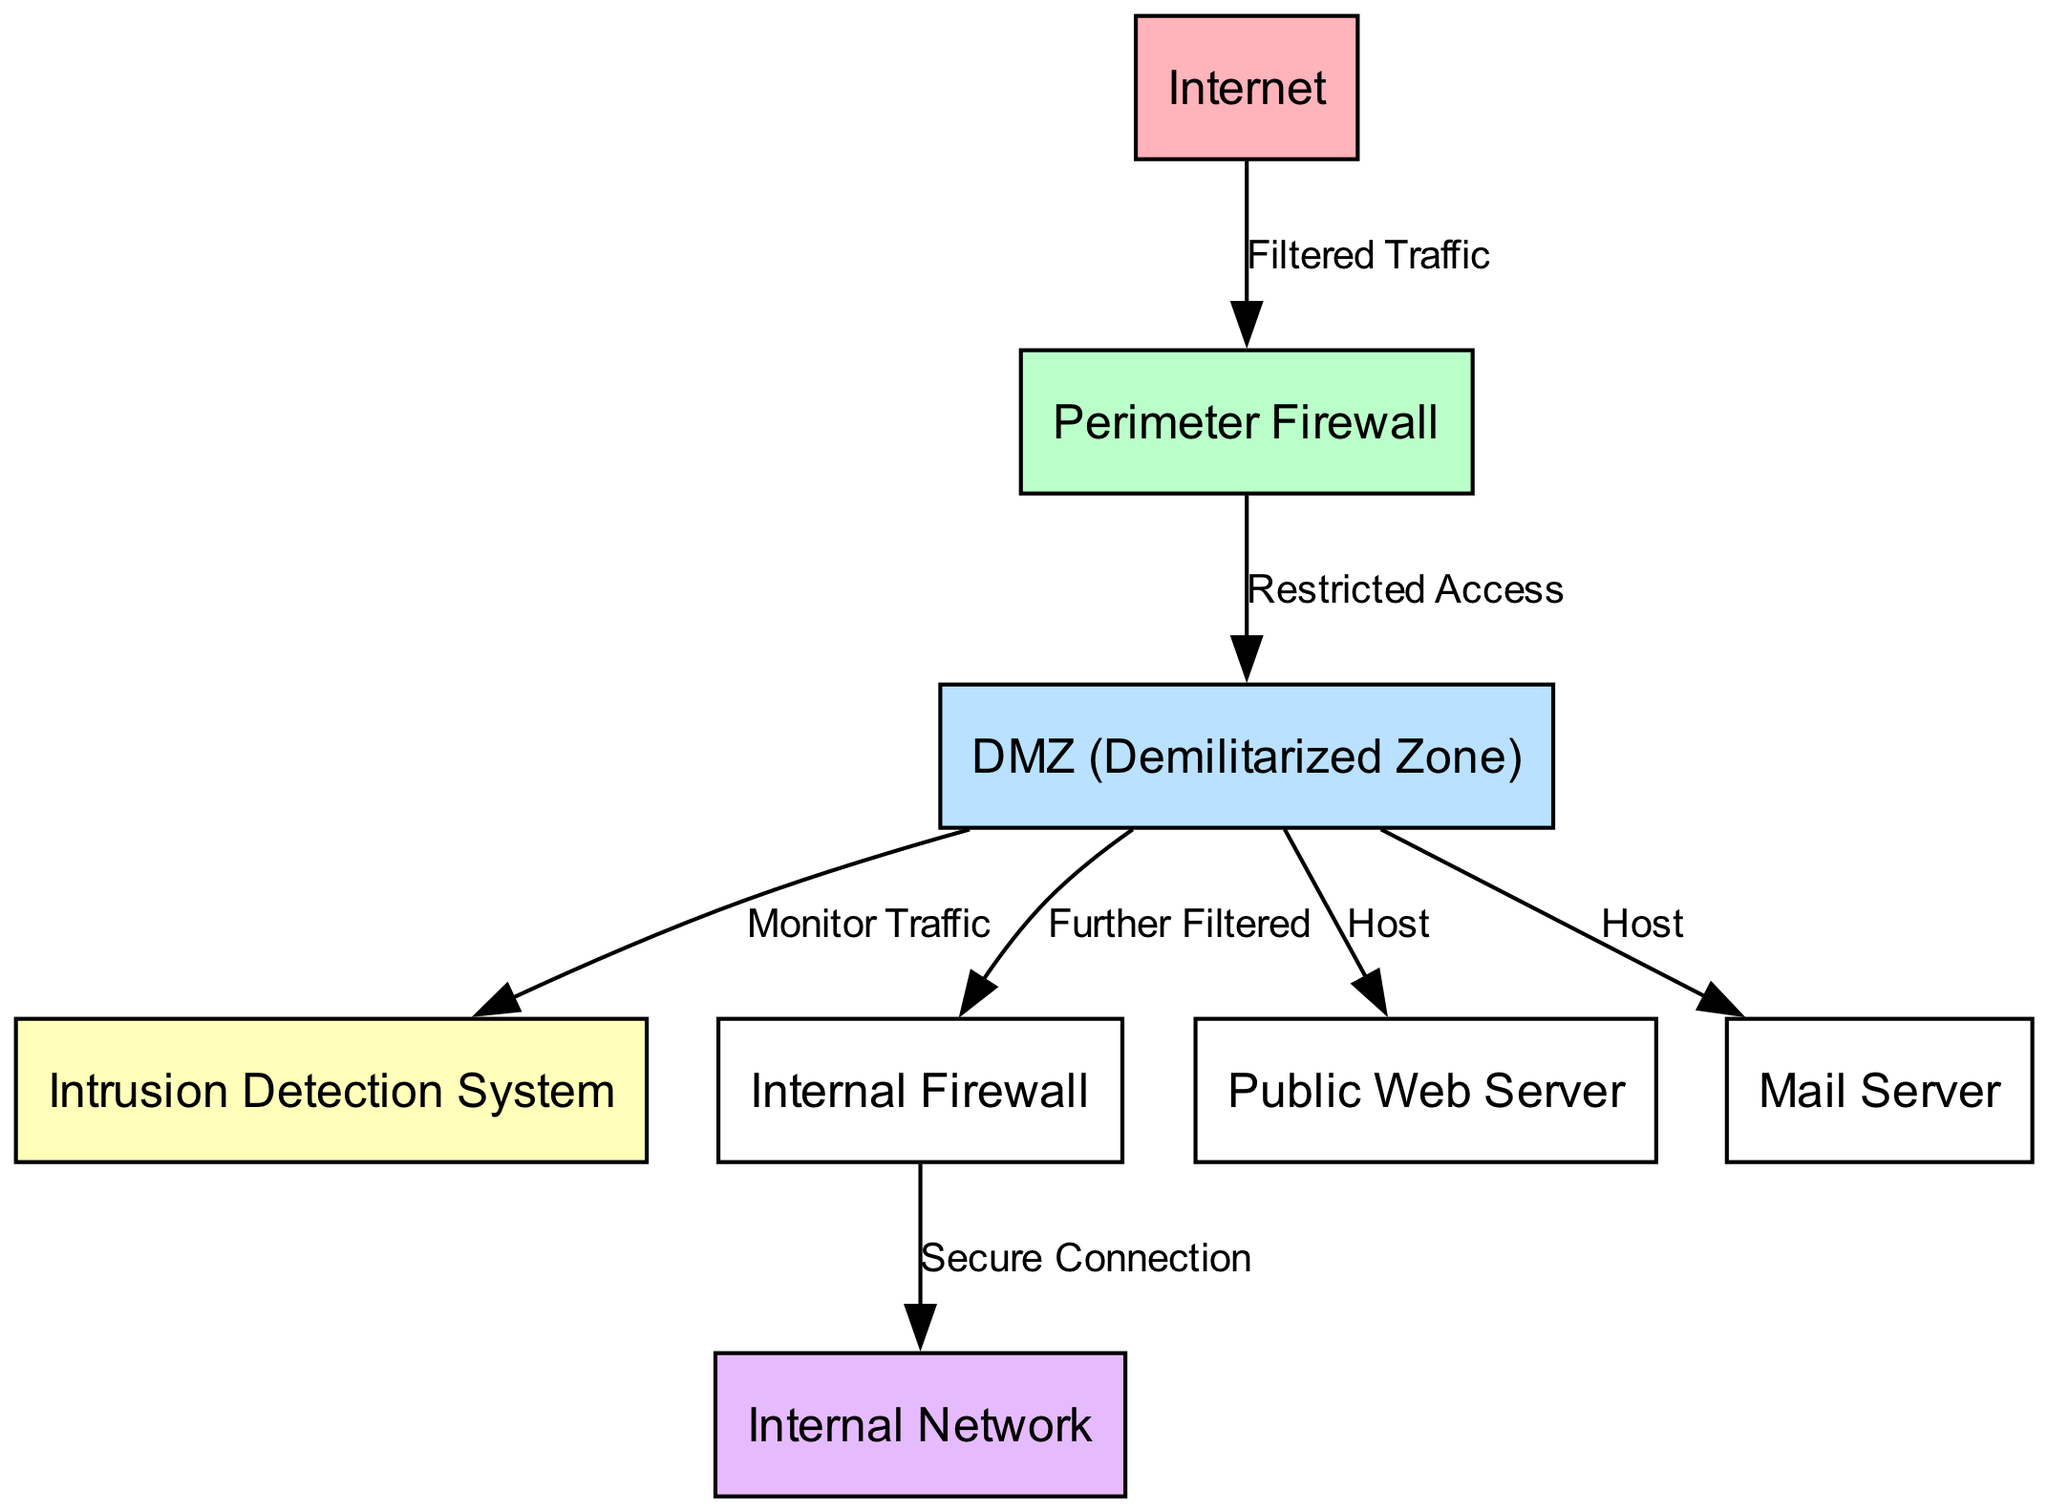What's the total number of nodes in the diagram? The diagram lists all the elements as nodes, which include Internet, Perimeter Firewall, DMZ, Intrusion Detection System, Internal Firewall, Internal Network, Public Web Server, and Mail Server. Adding these gives a total of 8 nodes.
Answer: 8 What does the Perimeter Firewall filter? The edge leading from the Internet to the Perimeter Firewall is labeled "Filtered Traffic", indicating that the Perimeter Firewall filters incoming traffic from the Internet.
Answer: Incoming traffic What are two hosts located in the DMZ? The nodes directly connected to the DMZ with the label "Host" are the Public Web Server and the Mail Server. These two servers serve as hosts in the DMZ area.
Answer: Public Web Server and Mail Server What connects the DMZ to the Internal Firewall? The edge between the DMZ and the Internal Firewall is labeled "Further Filtered". This means that the connection between these two nodes allows for further filtering of processes before reaching internal systems.
Answer: Further Filtered What type of system monitors traffic in the DMZ? The node labeled "Intrusion Detection System" (IDS) is directly connected to the DMZ, with the edge label "Monitor Traffic", indicating that this system is responsible for monitoring the traffic flowing through the DMZ.
Answer: Intrusion Detection System Which node represents a secure connection to the internal network? The edge leading from the Internal Firewall to the Internal Network is labeled "Secure Connection". This specifies that this connection is designed to be secure, protecting the integrity of the internal network.
Answer: Secure Connection How many edges are present in the diagram? Analyzing the connections (or edges) given in the diagram, there are a total of 6 edges connecting the nodes. Each connection is defined with directional relationships between pairs of nodes.
Answer: 6 What is the purpose of the DMZ in this security architecture? The DMZ serves as a buffer zone where public-facing servers, like the web server and mail server, are located. It allows external access while providing an additional layer of security before reaching the internal network.
Answer: Buffer zone for public-facing servers 